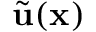Convert formula to latex. <formula><loc_0><loc_0><loc_500><loc_500>\widetilde { u } ( x )</formula> 